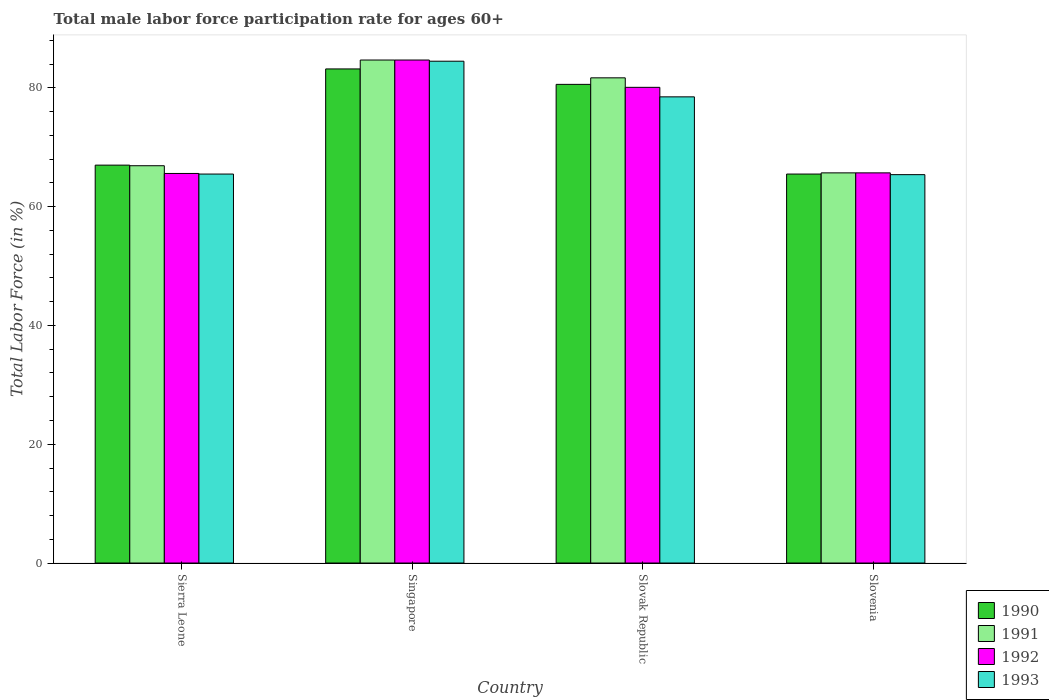How many different coloured bars are there?
Your response must be concise. 4. Are the number of bars per tick equal to the number of legend labels?
Make the answer very short. Yes. How many bars are there on the 3rd tick from the left?
Offer a terse response. 4. What is the label of the 3rd group of bars from the left?
Your response must be concise. Slovak Republic. In how many cases, is the number of bars for a given country not equal to the number of legend labels?
Your response must be concise. 0. What is the male labor force participation rate in 1991 in Singapore?
Your response must be concise. 84.7. Across all countries, what is the maximum male labor force participation rate in 1991?
Offer a very short reply. 84.7. Across all countries, what is the minimum male labor force participation rate in 1993?
Ensure brevity in your answer.  65.4. In which country was the male labor force participation rate in 1993 maximum?
Offer a very short reply. Singapore. In which country was the male labor force participation rate in 1991 minimum?
Your answer should be compact. Slovenia. What is the total male labor force participation rate in 1990 in the graph?
Provide a succinct answer. 296.3. What is the difference between the male labor force participation rate in 1990 in Slovak Republic and the male labor force participation rate in 1993 in Sierra Leone?
Offer a terse response. 15.1. What is the average male labor force participation rate in 1991 per country?
Make the answer very short. 74.75. What is the difference between the male labor force participation rate of/in 1992 and male labor force participation rate of/in 1990 in Slovenia?
Your response must be concise. 0.2. What is the ratio of the male labor force participation rate in 1993 in Sierra Leone to that in Slovenia?
Provide a short and direct response. 1. Is the male labor force participation rate in 1990 in Slovak Republic less than that in Slovenia?
Keep it short and to the point. No. Is the difference between the male labor force participation rate in 1992 in Singapore and Slovak Republic greater than the difference between the male labor force participation rate in 1990 in Singapore and Slovak Republic?
Your answer should be compact. Yes. What is the difference between the highest and the second highest male labor force participation rate in 1991?
Offer a very short reply. 14.8. What is the difference between the highest and the lowest male labor force participation rate in 1993?
Your response must be concise. 19.1. In how many countries, is the male labor force participation rate in 1991 greater than the average male labor force participation rate in 1991 taken over all countries?
Your answer should be compact. 2. Is it the case that in every country, the sum of the male labor force participation rate in 1990 and male labor force participation rate in 1992 is greater than the sum of male labor force participation rate in 1993 and male labor force participation rate in 1991?
Your answer should be very brief. No. How many bars are there?
Make the answer very short. 16. Are all the bars in the graph horizontal?
Offer a very short reply. No. How many countries are there in the graph?
Your answer should be compact. 4. Are the values on the major ticks of Y-axis written in scientific E-notation?
Provide a short and direct response. No. Does the graph contain any zero values?
Give a very brief answer. No. Where does the legend appear in the graph?
Make the answer very short. Bottom right. How are the legend labels stacked?
Your answer should be compact. Vertical. What is the title of the graph?
Your response must be concise. Total male labor force participation rate for ages 60+. What is the Total Labor Force (in %) of 1990 in Sierra Leone?
Your answer should be compact. 67. What is the Total Labor Force (in %) in 1991 in Sierra Leone?
Offer a very short reply. 66.9. What is the Total Labor Force (in %) in 1992 in Sierra Leone?
Provide a short and direct response. 65.6. What is the Total Labor Force (in %) in 1993 in Sierra Leone?
Provide a short and direct response. 65.5. What is the Total Labor Force (in %) of 1990 in Singapore?
Offer a very short reply. 83.2. What is the Total Labor Force (in %) of 1991 in Singapore?
Ensure brevity in your answer.  84.7. What is the Total Labor Force (in %) of 1992 in Singapore?
Offer a very short reply. 84.7. What is the Total Labor Force (in %) of 1993 in Singapore?
Ensure brevity in your answer.  84.5. What is the Total Labor Force (in %) of 1990 in Slovak Republic?
Offer a terse response. 80.6. What is the Total Labor Force (in %) in 1991 in Slovak Republic?
Your answer should be very brief. 81.7. What is the Total Labor Force (in %) in 1992 in Slovak Republic?
Your answer should be very brief. 80.1. What is the Total Labor Force (in %) of 1993 in Slovak Republic?
Your response must be concise. 78.5. What is the Total Labor Force (in %) in 1990 in Slovenia?
Your answer should be very brief. 65.5. What is the Total Labor Force (in %) in 1991 in Slovenia?
Offer a very short reply. 65.7. What is the Total Labor Force (in %) in 1992 in Slovenia?
Give a very brief answer. 65.7. What is the Total Labor Force (in %) of 1993 in Slovenia?
Provide a succinct answer. 65.4. Across all countries, what is the maximum Total Labor Force (in %) in 1990?
Offer a terse response. 83.2. Across all countries, what is the maximum Total Labor Force (in %) of 1991?
Offer a terse response. 84.7. Across all countries, what is the maximum Total Labor Force (in %) in 1992?
Provide a short and direct response. 84.7. Across all countries, what is the maximum Total Labor Force (in %) in 1993?
Your answer should be very brief. 84.5. Across all countries, what is the minimum Total Labor Force (in %) of 1990?
Provide a short and direct response. 65.5. Across all countries, what is the minimum Total Labor Force (in %) of 1991?
Offer a very short reply. 65.7. Across all countries, what is the minimum Total Labor Force (in %) of 1992?
Give a very brief answer. 65.6. Across all countries, what is the minimum Total Labor Force (in %) in 1993?
Make the answer very short. 65.4. What is the total Total Labor Force (in %) of 1990 in the graph?
Provide a short and direct response. 296.3. What is the total Total Labor Force (in %) in 1991 in the graph?
Offer a very short reply. 299. What is the total Total Labor Force (in %) in 1992 in the graph?
Make the answer very short. 296.1. What is the total Total Labor Force (in %) of 1993 in the graph?
Ensure brevity in your answer.  293.9. What is the difference between the Total Labor Force (in %) of 1990 in Sierra Leone and that in Singapore?
Provide a succinct answer. -16.2. What is the difference between the Total Labor Force (in %) in 1991 in Sierra Leone and that in Singapore?
Give a very brief answer. -17.8. What is the difference between the Total Labor Force (in %) of 1992 in Sierra Leone and that in Singapore?
Keep it short and to the point. -19.1. What is the difference between the Total Labor Force (in %) of 1993 in Sierra Leone and that in Singapore?
Provide a short and direct response. -19. What is the difference between the Total Labor Force (in %) of 1991 in Sierra Leone and that in Slovak Republic?
Provide a short and direct response. -14.8. What is the difference between the Total Labor Force (in %) of 1992 in Sierra Leone and that in Slovak Republic?
Your answer should be compact. -14.5. What is the difference between the Total Labor Force (in %) of 1991 in Sierra Leone and that in Slovenia?
Provide a succinct answer. 1.2. What is the difference between the Total Labor Force (in %) of 1992 in Sierra Leone and that in Slovenia?
Keep it short and to the point. -0.1. What is the difference between the Total Labor Force (in %) of 1991 in Singapore and that in Slovak Republic?
Give a very brief answer. 3. What is the difference between the Total Labor Force (in %) in 1992 in Singapore and that in Slovak Republic?
Your answer should be very brief. 4.6. What is the difference between the Total Labor Force (in %) of 1993 in Singapore and that in Slovak Republic?
Provide a short and direct response. 6. What is the difference between the Total Labor Force (in %) of 1992 in Singapore and that in Slovenia?
Make the answer very short. 19. What is the difference between the Total Labor Force (in %) in 1990 in Sierra Leone and the Total Labor Force (in %) in 1991 in Singapore?
Give a very brief answer. -17.7. What is the difference between the Total Labor Force (in %) of 1990 in Sierra Leone and the Total Labor Force (in %) of 1992 in Singapore?
Keep it short and to the point. -17.7. What is the difference between the Total Labor Force (in %) in 1990 in Sierra Leone and the Total Labor Force (in %) in 1993 in Singapore?
Offer a terse response. -17.5. What is the difference between the Total Labor Force (in %) in 1991 in Sierra Leone and the Total Labor Force (in %) in 1992 in Singapore?
Offer a very short reply. -17.8. What is the difference between the Total Labor Force (in %) of 1991 in Sierra Leone and the Total Labor Force (in %) of 1993 in Singapore?
Your answer should be very brief. -17.6. What is the difference between the Total Labor Force (in %) in 1992 in Sierra Leone and the Total Labor Force (in %) in 1993 in Singapore?
Your answer should be very brief. -18.9. What is the difference between the Total Labor Force (in %) in 1990 in Sierra Leone and the Total Labor Force (in %) in 1991 in Slovak Republic?
Give a very brief answer. -14.7. What is the difference between the Total Labor Force (in %) of 1990 in Sierra Leone and the Total Labor Force (in %) of 1991 in Slovenia?
Provide a short and direct response. 1.3. What is the difference between the Total Labor Force (in %) of 1990 in Sierra Leone and the Total Labor Force (in %) of 1992 in Slovenia?
Your response must be concise. 1.3. What is the difference between the Total Labor Force (in %) of 1990 in Sierra Leone and the Total Labor Force (in %) of 1993 in Slovenia?
Provide a short and direct response. 1.6. What is the difference between the Total Labor Force (in %) of 1991 in Sierra Leone and the Total Labor Force (in %) of 1992 in Slovenia?
Provide a succinct answer. 1.2. What is the difference between the Total Labor Force (in %) of 1991 in Sierra Leone and the Total Labor Force (in %) of 1993 in Slovenia?
Ensure brevity in your answer.  1.5. What is the difference between the Total Labor Force (in %) in 1992 in Sierra Leone and the Total Labor Force (in %) in 1993 in Slovenia?
Offer a very short reply. 0.2. What is the difference between the Total Labor Force (in %) of 1991 in Singapore and the Total Labor Force (in %) of 1993 in Slovak Republic?
Ensure brevity in your answer.  6.2. What is the difference between the Total Labor Force (in %) of 1992 in Singapore and the Total Labor Force (in %) of 1993 in Slovak Republic?
Your response must be concise. 6.2. What is the difference between the Total Labor Force (in %) in 1991 in Singapore and the Total Labor Force (in %) in 1993 in Slovenia?
Make the answer very short. 19.3. What is the difference between the Total Labor Force (in %) of 1992 in Singapore and the Total Labor Force (in %) of 1993 in Slovenia?
Your response must be concise. 19.3. What is the difference between the Total Labor Force (in %) in 1990 in Slovak Republic and the Total Labor Force (in %) in 1991 in Slovenia?
Ensure brevity in your answer.  14.9. What is the difference between the Total Labor Force (in %) in 1990 in Slovak Republic and the Total Labor Force (in %) in 1992 in Slovenia?
Your answer should be very brief. 14.9. What is the difference between the Total Labor Force (in %) of 1991 in Slovak Republic and the Total Labor Force (in %) of 1992 in Slovenia?
Provide a succinct answer. 16. What is the average Total Labor Force (in %) of 1990 per country?
Provide a succinct answer. 74.08. What is the average Total Labor Force (in %) in 1991 per country?
Offer a very short reply. 74.75. What is the average Total Labor Force (in %) of 1992 per country?
Ensure brevity in your answer.  74.03. What is the average Total Labor Force (in %) in 1993 per country?
Offer a terse response. 73.47. What is the difference between the Total Labor Force (in %) of 1990 and Total Labor Force (in %) of 1992 in Sierra Leone?
Your answer should be compact. 1.4. What is the difference between the Total Labor Force (in %) of 1990 and Total Labor Force (in %) of 1993 in Sierra Leone?
Offer a very short reply. 1.5. What is the difference between the Total Labor Force (in %) in 1990 and Total Labor Force (in %) in 1992 in Singapore?
Keep it short and to the point. -1.5. What is the difference between the Total Labor Force (in %) of 1990 and Total Labor Force (in %) of 1993 in Singapore?
Ensure brevity in your answer.  -1.3. What is the difference between the Total Labor Force (in %) in 1991 and Total Labor Force (in %) in 1993 in Singapore?
Give a very brief answer. 0.2. What is the difference between the Total Labor Force (in %) of 1991 and Total Labor Force (in %) of 1993 in Slovak Republic?
Give a very brief answer. 3.2. What is the difference between the Total Labor Force (in %) in 1990 and Total Labor Force (in %) in 1991 in Slovenia?
Your answer should be compact. -0.2. What is the difference between the Total Labor Force (in %) in 1991 and Total Labor Force (in %) in 1992 in Slovenia?
Provide a succinct answer. 0. What is the difference between the Total Labor Force (in %) of 1991 and Total Labor Force (in %) of 1993 in Slovenia?
Your answer should be compact. 0.3. What is the ratio of the Total Labor Force (in %) in 1990 in Sierra Leone to that in Singapore?
Ensure brevity in your answer.  0.81. What is the ratio of the Total Labor Force (in %) in 1991 in Sierra Leone to that in Singapore?
Ensure brevity in your answer.  0.79. What is the ratio of the Total Labor Force (in %) of 1992 in Sierra Leone to that in Singapore?
Ensure brevity in your answer.  0.77. What is the ratio of the Total Labor Force (in %) in 1993 in Sierra Leone to that in Singapore?
Keep it short and to the point. 0.78. What is the ratio of the Total Labor Force (in %) in 1990 in Sierra Leone to that in Slovak Republic?
Ensure brevity in your answer.  0.83. What is the ratio of the Total Labor Force (in %) of 1991 in Sierra Leone to that in Slovak Republic?
Your answer should be compact. 0.82. What is the ratio of the Total Labor Force (in %) in 1992 in Sierra Leone to that in Slovak Republic?
Your answer should be compact. 0.82. What is the ratio of the Total Labor Force (in %) of 1993 in Sierra Leone to that in Slovak Republic?
Keep it short and to the point. 0.83. What is the ratio of the Total Labor Force (in %) of 1990 in Sierra Leone to that in Slovenia?
Offer a terse response. 1.02. What is the ratio of the Total Labor Force (in %) in 1991 in Sierra Leone to that in Slovenia?
Offer a very short reply. 1.02. What is the ratio of the Total Labor Force (in %) in 1993 in Sierra Leone to that in Slovenia?
Your answer should be very brief. 1. What is the ratio of the Total Labor Force (in %) of 1990 in Singapore to that in Slovak Republic?
Make the answer very short. 1.03. What is the ratio of the Total Labor Force (in %) in 1991 in Singapore to that in Slovak Republic?
Your response must be concise. 1.04. What is the ratio of the Total Labor Force (in %) in 1992 in Singapore to that in Slovak Republic?
Make the answer very short. 1.06. What is the ratio of the Total Labor Force (in %) in 1993 in Singapore to that in Slovak Republic?
Offer a very short reply. 1.08. What is the ratio of the Total Labor Force (in %) of 1990 in Singapore to that in Slovenia?
Your response must be concise. 1.27. What is the ratio of the Total Labor Force (in %) of 1991 in Singapore to that in Slovenia?
Offer a very short reply. 1.29. What is the ratio of the Total Labor Force (in %) of 1992 in Singapore to that in Slovenia?
Offer a very short reply. 1.29. What is the ratio of the Total Labor Force (in %) in 1993 in Singapore to that in Slovenia?
Offer a terse response. 1.29. What is the ratio of the Total Labor Force (in %) of 1990 in Slovak Republic to that in Slovenia?
Make the answer very short. 1.23. What is the ratio of the Total Labor Force (in %) of 1991 in Slovak Republic to that in Slovenia?
Make the answer very short. 1.24. What is the ratio of the Total Labor Force (in %) in 1992 in Slovak Republic to that in Slovenia?
Make the answer very short. 1.22. What is the ratio of the Total Labor Force (in %) in 1993 in Slovak Republic to that in Slovenia?
Make the answer very short. 1.2. What is the difference between the highest and the second highest Total Labor Force (in %) in 1990?
Your answer should be very brief. 2.6. What is the difference between the highest and the lowest Total Labor Force (in %) in 1990?
Your answer should be very brief. 17.7. What is the difference between the highest and the lowest Total Labor Force (in %) in 1991?
Provide a short and direct response. 19. What is the difference between the highest and the lowest Total Labor Force (in %) of 1993?
Your response must be concise. 19.1. 